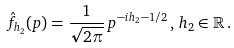<formula> <loc_0><loc_0><loc_500><loc_500>\hat { f } _ { h _ { 2 } } ( p ) = \frac { 1 } { \sqrt { 2 \pi } } \, p ^ { - i h _ { 2 } - 1 / 2 } \, , \, h _ { 2 } \in \mathbb { R } \, .</formula> 